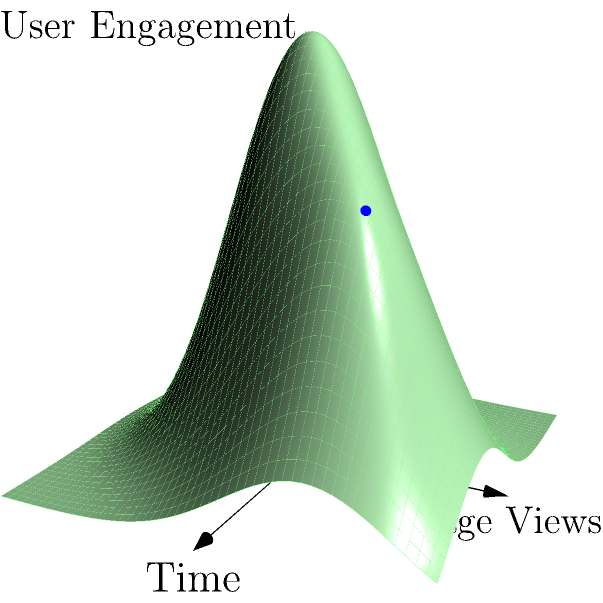As an online boutique owner, you're analyzing website traffic patterns using a 3D coordinate system where the x-axis represents time, the y-axis represents page views, and the z-axis represents user engagement. The graph shows two distinct peaks. Which peak (red or blue) likely represents a more valuable user interaction for your boutique, and why? To determine which peak represents a more valuable user interaction, let's analyze the graph step-by-step:

1. Observe the two peaks:
   - Red peak: located at (0,0,z1)
   - Blue peak: located at (1,1,z2)

2. Interpret the coordinates:
   - x-coordinate: represents time
   - y-coordinate: represents page views
   - z-coordinate: represents user engagement

3. Compare the peaks:
   - Red peak (0,0,z1):
     * Lower time value
     * Lower page views
     * Higher engagement (taller peak)
   - Blue peak (1,1,z2):
     * Higher time value
     * Higher page views
     * Slightly lower engagement

4. Analyze the implications:
   - Red peak: High engagement but low page views might indicate a quick, focused interaction (e.g., a returning customer making a fast purchase)
   - Blue peak: Higher page views and time spent, with good engagement, suggests a more exploratory visit (e.g., a new customer browsing multiple products)

5. Consider the business context:
   - As an online boutique, you want customers to explore multiple products (higher page views) and spend more time on the site, increasing the likelihood of purchases and brand familiarity

6. Conclusion:
   The blue peak likely represents a more valuable user interaction for your boutique because it shows higher page views and time spent, indicating a more thorough exploration of your products, which can lead to increased sales and brand awareness.
Answer: Blue peak; higher page views and time spent indicate more product exploration, potentially leading to increased sales and brand awareness. 